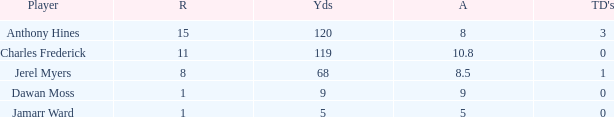What is the total Avg when TDs are 0 and Dawan Moss is a player? 0.0. 